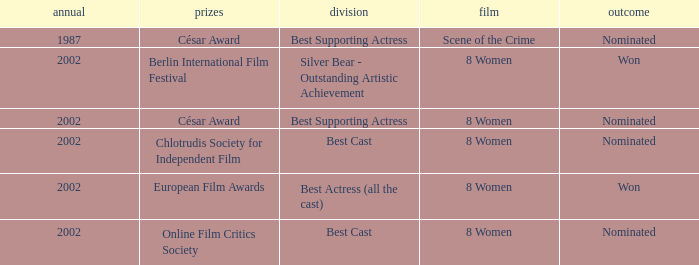What was the categorie in 2002 at the Berlin international Film Festival that Danielle Darrieux was in? Silver Bear - Outstanding Artistic Achievement. 